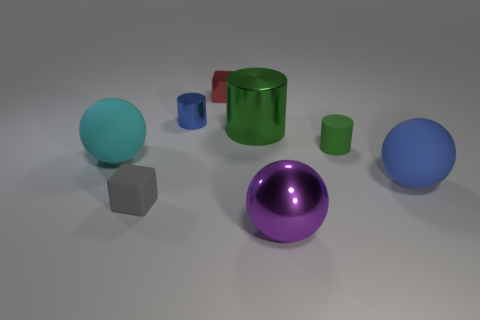Are there any other metal things of the same size as the red thing? Yes, several objects in the image appear to be metallic and of similar size to the red cylinder. For example, the green cylinder and the small blue sphere can be considered close in size. 